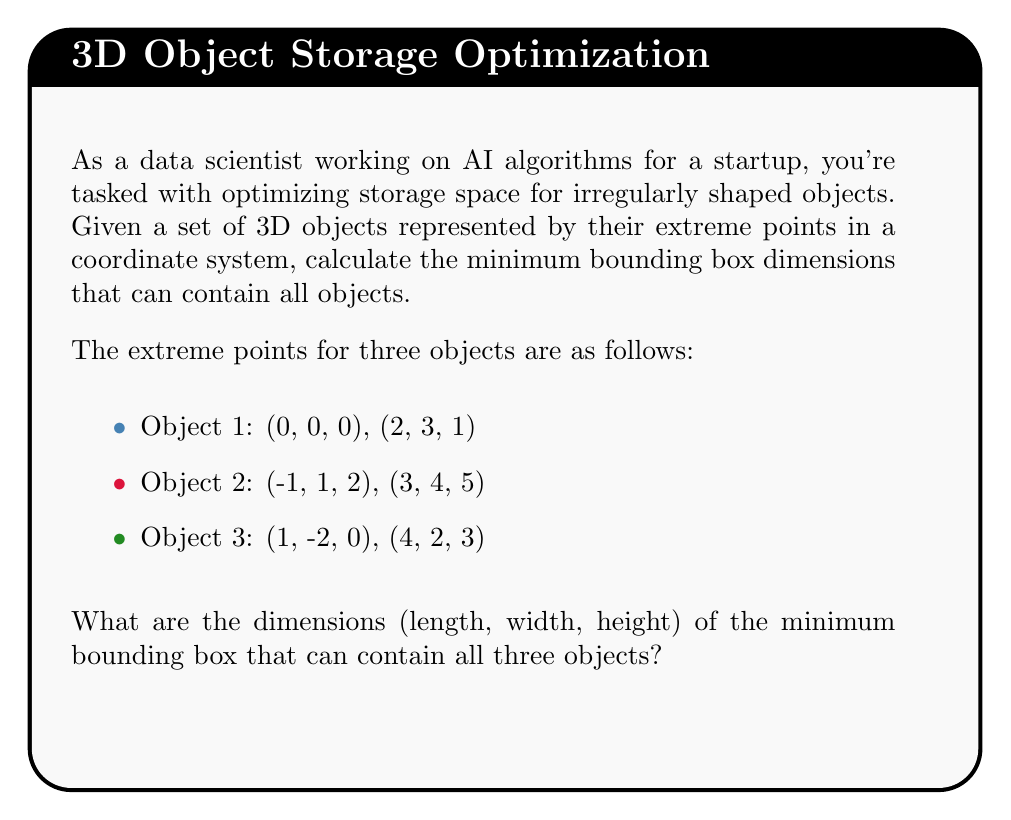Show me your answer to this math problem. To find the minimum bounding box dimensions, we need to determine the extreme points in each dimension (x, y, and z) across all objects. Let's approach this step-by-step:

1. Identify the minimum and maximum values for each dimension:

   x-dimension:
   Min: min(-1, 0, 1) = -1
   Max: max(3, 4, 4) = 4

   y-dimension:
   Min: min(-2, 0, 1) = -2
   Max: max(3, 4, 2) = 4

   z-dimension:
   Min: min(0, 0, 2) = 0
   Max: max(1, 5, 3) = 5

2. Calculate the dimensions of the bounding box:

   Length (x-dimension): $4 - (-1) = 5$
   Width (y-dimension): $4 - (-2) = 6$
   Height (z-dimension): $5 - 0 = 5$

3. Express the dimensions as a vector:

   $$\text{Dimensions} = (5, 6, 5)$$

The minimum bounding box that can contain all three objects has dimensions 5 units in length, 6 units in width, and 5 units in height.
Answer: $(5, 6, 5)$ 